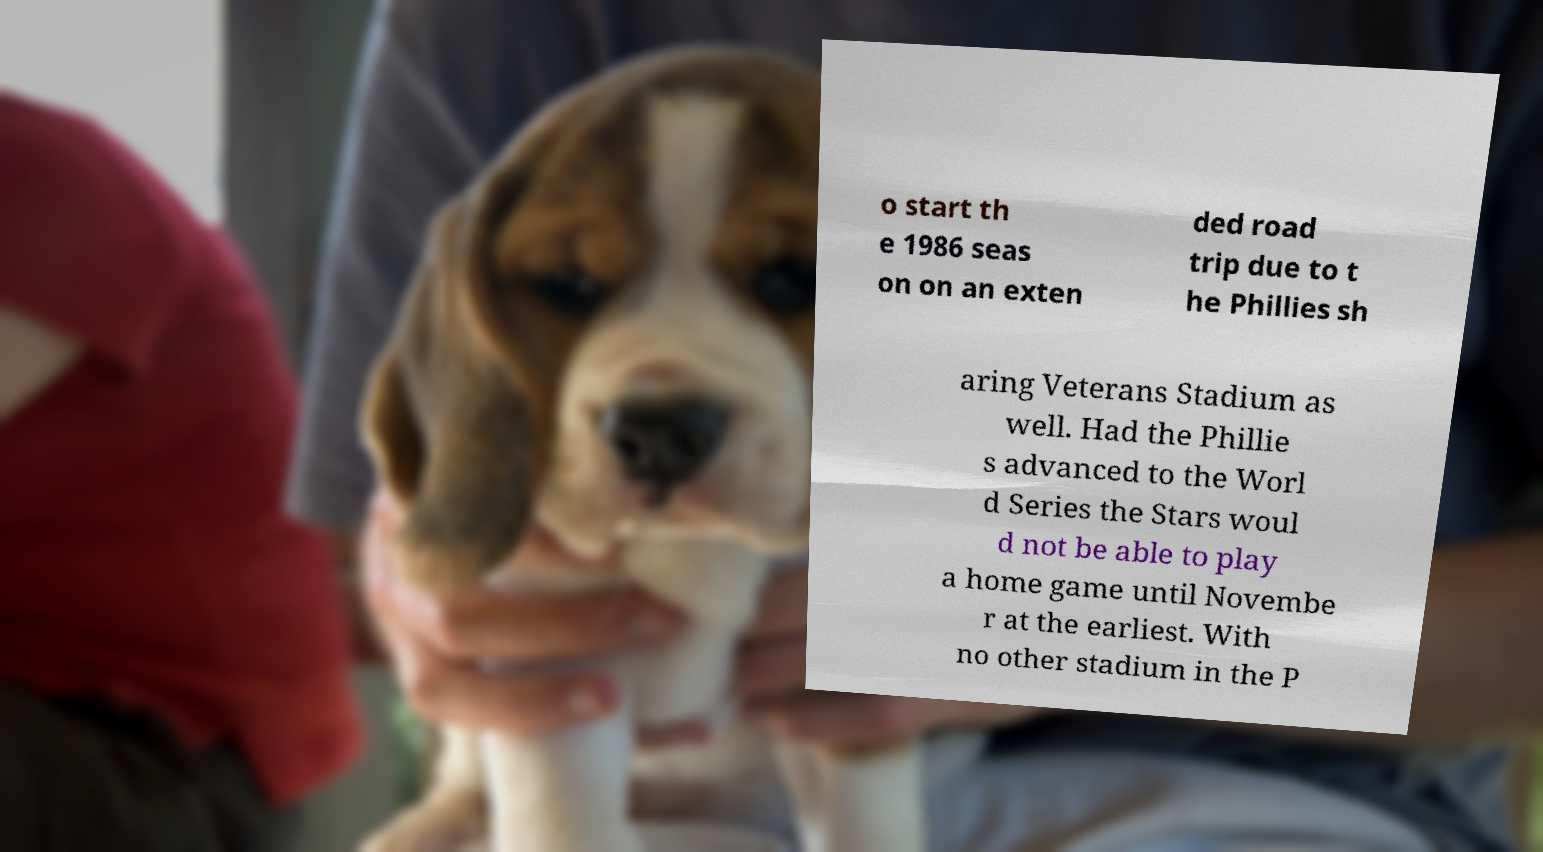For documentation purposes, I need the text within this image transcribed. Could you provide that? o start th e 1986 seas on on an exten ded road trip due to t he Phillies sh aring Veterans Stadium as well. Had the Phillie s advanced to the Worl d Series the Stars woul d not be able to play a home game until Novembe r at the earliest. With no other stadium in the P 